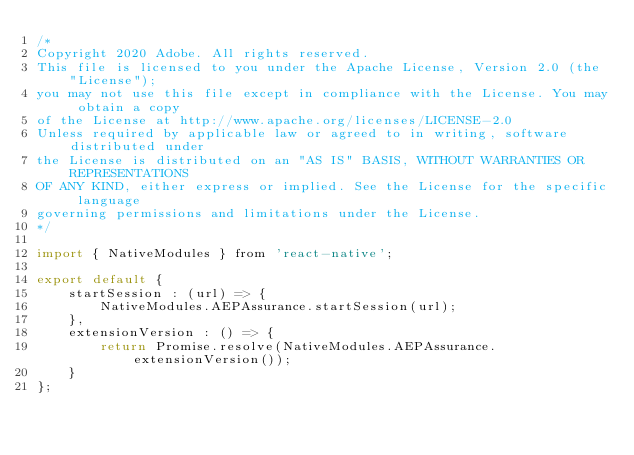<code> <loc_0><loc_0><loc_500><loc_500><_JavaScript_>/*
Copyright 2020 Adobe. All rights reserved.
This file is licensed to you under the Apache License, Version 2.0 (the "License");
you may not use this file except in compliance with the License. You may obtain a copy
of the License at http://www.apache.org/licenses/LICENSE-2.0
Unless required by applicable law or agreed to in writing, software distributed under
the License is distributed on an "AS IS" BASIS, WITHOUT WARRANTIES OR REPRESENTATIONS
OF ANY KIND, either express or implied. See the License for the specific language
governing permissions and limitations under the License.
*/

import { NativeModules } from 'react-native';

export default {
    startSession : (url) => {
        NativeModules.AEPAssurance.startSession(url);
    },
    extensionVersion : () => {
        return Promise.resolve(NativeModules.AEPAssurance.extensionVersion());
    }
};
</code> 